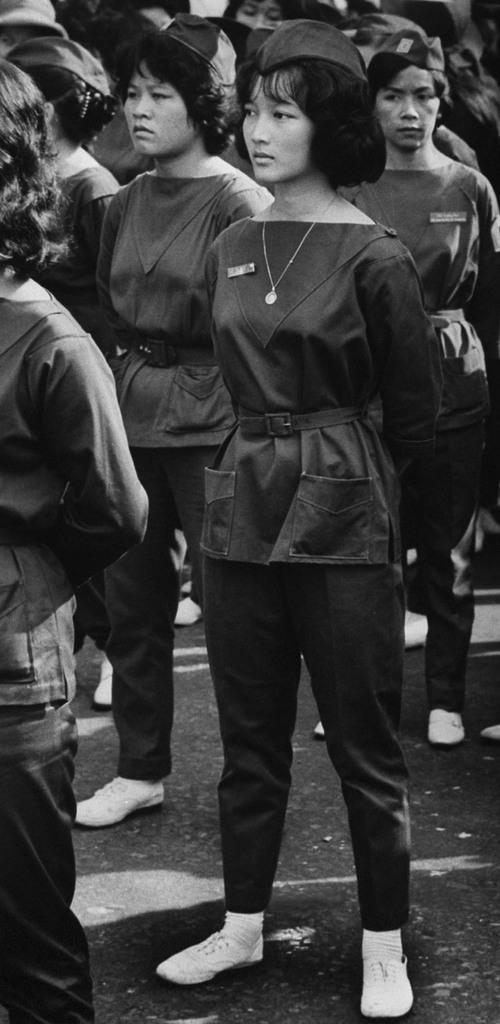What type of clothing are the girls wearing on their upper bodies in the image? The girls are wearing t-shirts in the image. What type of clothing are the girls wearing on their lower bodies in the image? The girls are wearing trousers in the image. What type of headwear are the girls wearing in the image? The girls are wearing caps in the image. What position are the girls in the image? The girls are standing in the image. What type of alarm can be heard going off in the image? There is no alarm present in the image; it is a still photograph of the girls. 